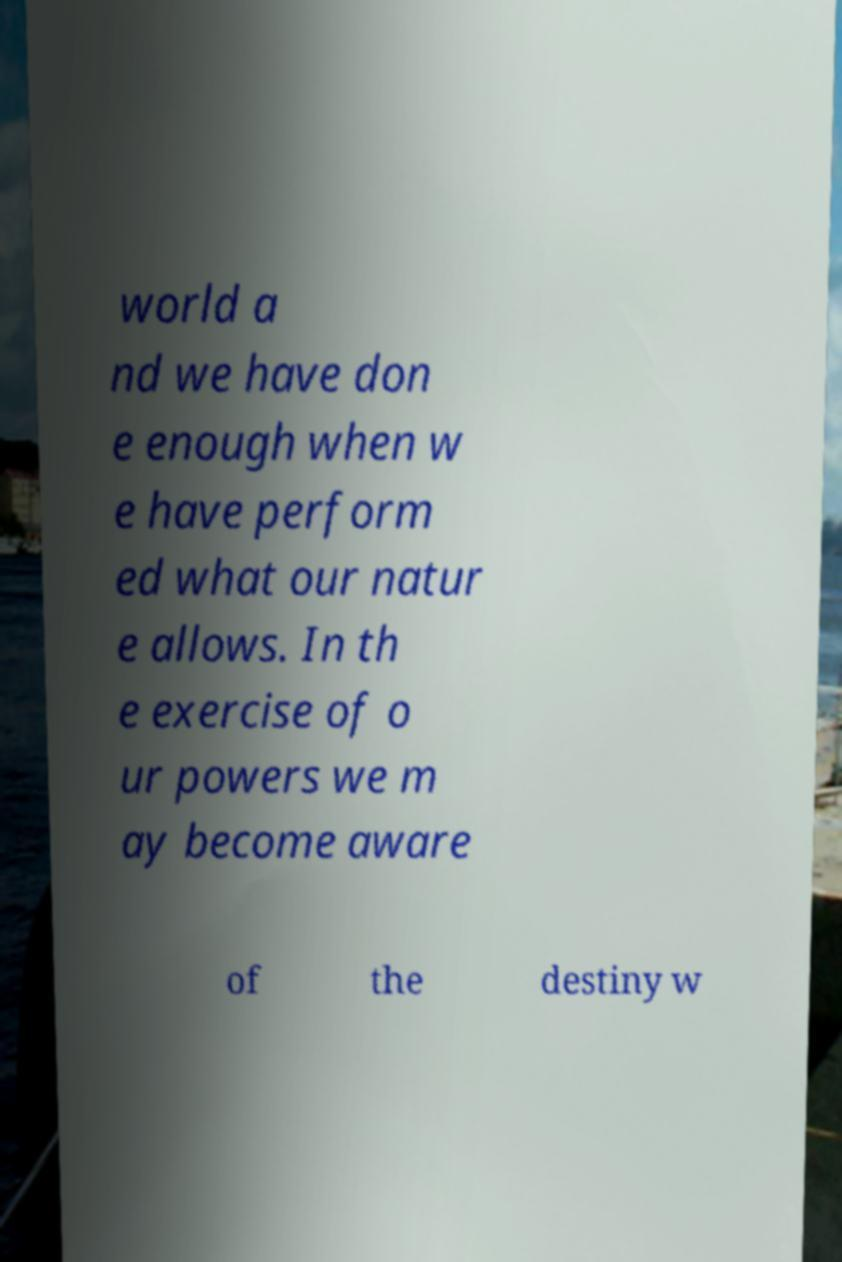Can you read and provide the text displayed in the image?This photo seems to have some interesting text. Can you extract and type it out for me? world a nd we have don e enough when w e have perform ed what our natur e allows. In th e exercise of o ur powers we m ay become aware of the destiny w 